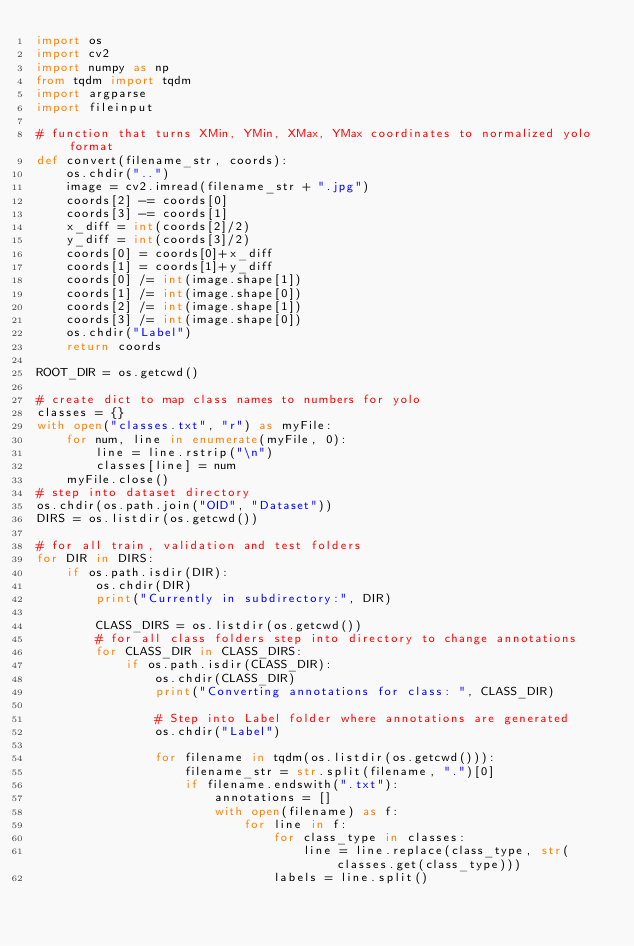Convert code to text. <code><loc_0><loc_0><loc_500><loc_500><_Python_>import os
import cv2
import numpy as np
from tqdm import tqdm
import argparse
import fileinput

# function that turns XMin, YMin, XMax, YMax coordinates to normalized yolo format
def convert(filename_str, coords):
    os.chdir("..")
    image = cv2.imread(filename_str + ".jpg")
    coords[2] -= coords[0]
    coords[3] -= coords[1]
    x_diff = int(coords[2]/2)
    y_diff = int(coords[3]/2)
    coords[0] = coords[0]+x_diff
    coords[1] = coords[1]+y_diff
    coords[0] /= int(image.shape[1])
    coords[1] /= int(image.shape[0])
    coords[2] /= int(image.shape[1])
    coords[3] /= int(image.shape[0])
    os.chdir("Label")
    return coords

ROOT_DIR = os.getcwd()

# create dict to map class names to numbers for yolo
classes = {}
with open("classes.txt", "r") as myFile:
    for num, line in enumerate(myFile, 0):
        line = line.rstrip("\n")
        classes[line] = num
    myFile.close()
# step into dataset directory
os.chdir(os.path.join("OID", "Dataset"))
DIRS = os.listdir(os.getcwd())

# for all train, validation and test folders
for DIR in DIRS:
    if os.path.isdir(DIR):
        os.chdir(DIR)
        print("Currently in subdirectory:", DIR)
        
        CLASS_DIRS = os.listdir(os.getcwd())
        # for all class folders step into directory to change annotations
        for CLASS_DIR in CLASS_DIRS:
            if os.path.isdir(CLASS_DIR):
                os.chdir(CLASS_DIR)
                print("Converting annotations for class: ", CLASS_DIR)
                
                # Step into Label folder where annotations are generated
                os.chdir("Label")

                for filename in tqdm(os.listdir(os.getcwd())):
                    filename_str = str.split(filename, ".")[0]
                    if filename.endswith(".txt"):
                        annotations = []
                        with open(filename) as f:
                            for line in f:
                                for class_type in classes:
                                    line = line.replace(class_type, str(classes.get(class_type)))
                                labels = line.split()</code> 